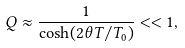Convert formula to latex. <formula><loc_0><loc_0><loc_500><loc_500>Q \approx \frac { 1 } { \cosh ( 2 \theta T / T _ { 0 } ) } < < 1 ,</formula> 